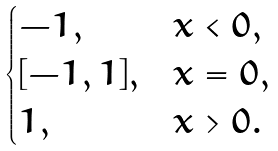Convert formula to latex. <formula><loc_0><loc_0><loc_500><loc_500>\begin{cases} - 1 , & x < 0 , \\ [ - 1 , 1 ] , & x = 0 , \\ 1 , & x > 0 . \end{cases}</formula> 